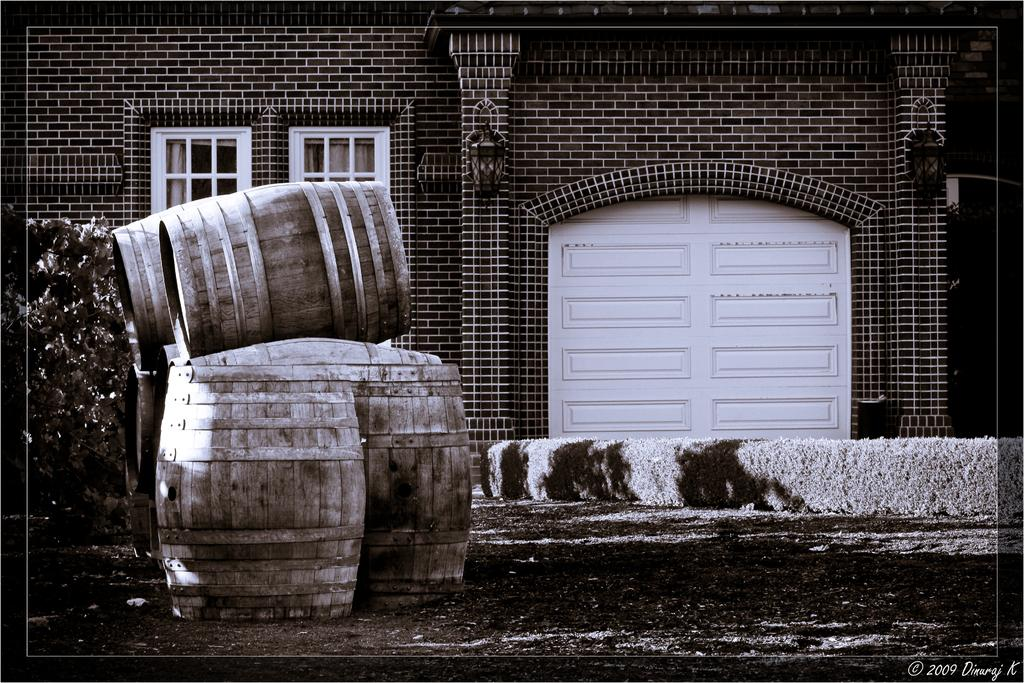What objects are present in the image? There are barrels and a plant in the image. Can you describe the building in the background of the image? There is a building with windows in the background of the image. What type of plastic is covering the sack in the image? There is no sack or plastic present in the image. How many times has the image been copied? The number of times the image has been copied is not relevant to the content of the image itself. 